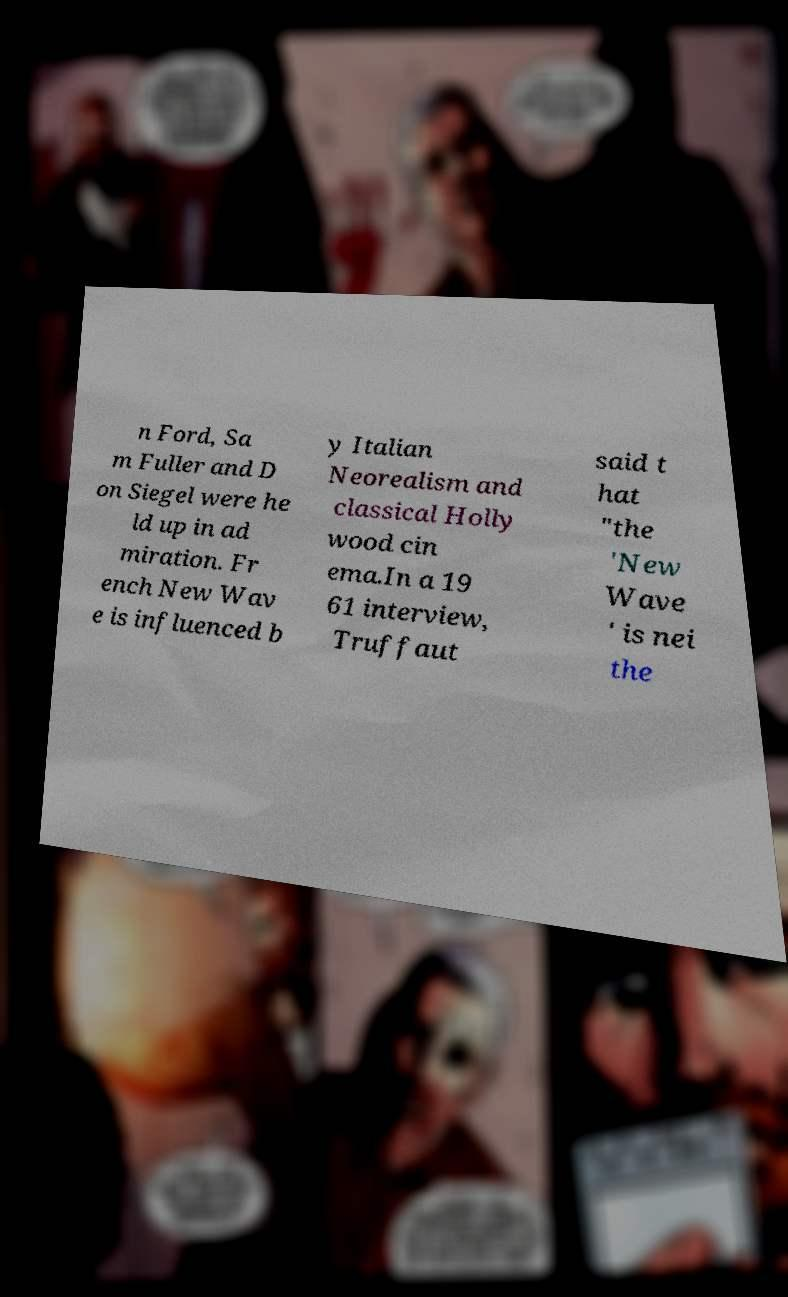I need the written content from this picture converted into text. Can you do that? n Ford, Sa m Fuller and D on Siegel were he ld up in ad miration. Fr ench New Wav e is influenced b y Italian Neorealism and classical Holly wood cin ema.In a 19 61 interview, Truffaut said t hat "the 'New Wave ' is nei the 